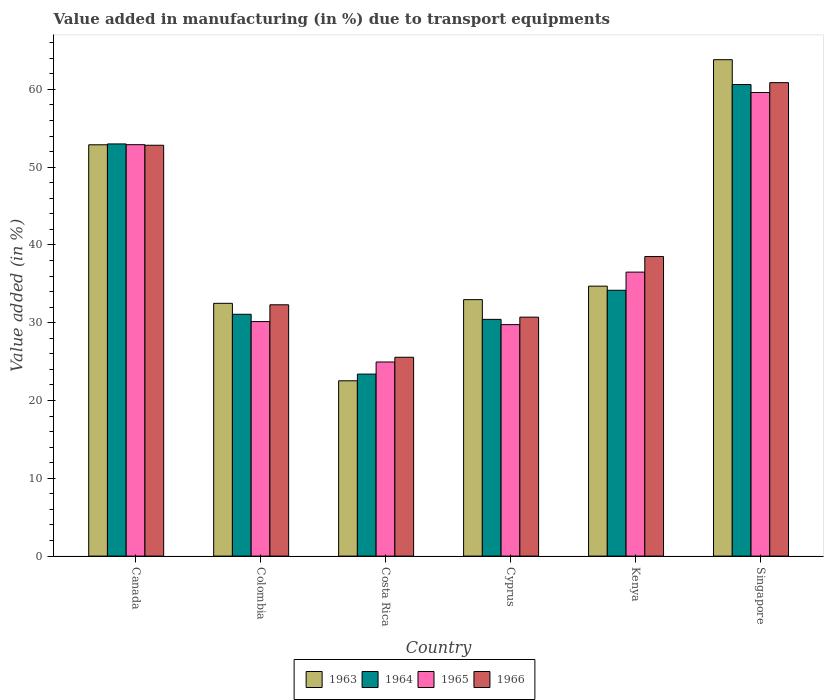How many different coloured bars are there?
Provide a succinct answer. 4. Are the number of bars per tick equal to the number of legend labels?
Your answer should be very brief. Yes. What is the label of the 1st group of bars from the left?
Your answer should be compact. Canada. In how many cases, is the number of bars for a given country not equal to the number of legend labels?
Offer a terse response. 0. What is the percentage of value added in manufacturing due to transport equipments in 1963 in Canada?
Ensure brevity in your answer.  52.87. Across all countries, what is the maximum percentage of value added in manufacturing due to transport equipments in 1965?
Your response must be concise. 59.59. Across all countries, what is the minimum percentage of value added in manufacturing due to transport equipments in 1963?
Your answer should be very brief. 22.53. In which country was the percentage of value added in manufacturing due to transport equipments in 1963 maximum?
Offer a terse response. Singapore. What is the total percentage of value added in manufacturing due to transport equipments in 1964 in the graph?
Make the answer very short. 232.68. What is the difference between the percentage of value added in manufacturing due to transport equipments in 1965 in Costa Rica and that in Kenya?
Make the answer very short. -11.55. What is the difference between the percentage of value added in manufacturing due to transport equipments in 1966 in Costa Rica and the percentage of value added in manufacturing due to transport equipments in 1964 in Cyprus?
Your answer should be compact. -4.87. What is the average percentage of value added in manufacturing due to transport equipments in 1965 per country?
Provide a short and direct response. 38.97. What is the difference between the percentage of value added in manufacturing due to transport equipments of/in 1965 and percentage of value added in manufacturing due to transport equipments of/in 1966 in Singapore?
Make the answer very short. -1.27. What is the ratio of the percentage of value added in manufacturing due to transport equipments in 1963 in Cyprus to that in Singapore?
Provide a succinct answer. 0.52. What is the difference between the highest and the second highest percentage of value added in manufacturing due to transport equipments in 1966?
Offer a terse response. -22.35. What is the difference between the highest and the lowest percentage of value added in manufacturing due to transport equipments in 1964?
Provide a succinct answer. 37.22. In how many countries, is the percentage of value added in manufacturing due to transport equipments in 1963 greater than the average percentage of value added in manufacturing due to transport equipments in 1963 taken over all countries?
Ensure brevity in your answer.  2. Is the sum of the percentage of value added in manufacturing due to transport equipments in 1964 in Colombia and Kenya greater than the maximum percentage of value added in manufacturing due to transport equipments in 1966 across all countries?
Your answer should be compact. Yes. Is it the case that in every country, the sum of the percentage of value added in manufacturing due to transport equipments in 1966 and percentage of value added in manufacturing due to transport equipments in 1964 is greater than the sum of percentage of value added in manufacturing due to transport equipments in 1965 and percentage of value added in manufacturing due to transport equipments in 1963?
Your answer should be very brief. No. What does the 2nd bar from the left in Singapore represents?
Provide a succinct answer. 1964. What does the 2nd bar from the right in Kenya represents?
Give a very brief answer. 1965. Is it the case that in every country, the sum of the percentage of value added in manufacturing due to transport equipments in 1963 and percentage of value added in manufacturing due to transport equipments in 1966 is greater than the percentage of value added in manufacturing due to transport equipments in 1964?
Make the answer very short. Yes. Are all the bars in the graph horizontal?
Your answer should be compact. No. What is the difference between two consecutive major ticks on the Y-axis?
Give a very brief answer. 10. Does the graph contain grids?
Keep it short and to the point. No. Where does the legend appear in the graph?
Keep it short and to the point. Bottom center. What is the title of the graph?
Keep it short and to the point. Value added in manufacturing (in %) due to transport equipments. What is the label or title of the Y-axis?
Make the answer very short. Value added (in %). What is the Value added (in %) of 1963 in Canada?
Your answer should be very brief. 52.87. What is the Value added (in %) in 1964 in Canada?
Make the answer very short. 52.98. What is the Value added (in %) of 1965 in Canada?
Your answer should be very brief. 52.89. What is the Value added (in %) in 1966 in Canada?
Your answer should be very brief. 52.81. What is the Value added (in %) in 1963 in Colombia?
Ensure brevity in your answer.  32.49. What is the Value added (in %) of 1964 in Colombia?
Offer a very short reply. 31.09. What is the Value added (in %) in 1965 in Colombia?
Your answer should be very brief. 30.15. What is the Value added (in %) in 1966 in Colombia?
Give a very brief answer. 32.3. What is the Value added (in %) of 1963 in Costa Rica?
Offer a very short reply. 22.53. What is the Value added (in %) in 1964 in Costa Rica?
Ensure brevity in your answer.  23.4. What is the Value added (in %) in 1965 in Costa Rica?
Your response must be concise. 24.95. What is the Value added (in %) in 1966 in Costa Rica?
Keep it short and to the point. 25.56. What is the Value added (in %) in 1963 in Cyprus?
Your answer should be very brief. 32.97. What is the Value added (in %) in 1964 in Cyprus?
Offer a terse response. 30.43. What is the Value added (in %) of 1965 in Cyprus?
Make the answer very short. 29.75. What is the Value added (in %) of 1966 in Cyprus?
Offer a very short reply. 30.72. What is the Value added (in %) of 1963 in Kenya?
Provide a short and direct response. 34.7. What is the Value added (in %) of 1964 in Kenya?
Your answer should be very brief. 34.17. What is the Value added (in %) of 1965 in Kenya?
Ensure brevity in your answer.  36.5. What is the Value added (in %) in 1966 in Kenya?
Your answer should be very brief. 38.51. What is the Value added (in %) of 1963 in Singapore?
Ensure brevity in your answer.  63.81. What is the Value added (in %) in 1964 in Singapore?
Offer a very short reply. 60.62. What is the Value added (in %) of 1965 in Singapore?
Provide a succinct answer. 59.59. What is the Value added (in %) in 1966 in Singapore?
Your answer should be compact. 60.86. Across all countries, what is the maximum Value added (in %) of 1963?
Make the answer very short. 63.81. Across all countries, what is the maximum Value added (in %) of 1964?
Keep it short and to the point. 60.62. Across all countries, what is the maximum Value added (in %) in 1965?
Your response must be concise. 59.59. Across all countries, what is the maximum Value added (in %) in 1966?
Provide a succinct answer. 60.86. Across all countries, what is the minimum Value added (in %) in 1963?
Make the answer very short. 22.53. Across all countries, what is the minimum Value added (in %) in 1964?
Keep it short and to the point. 23.4. Across all countries, what is the minimum Value added (in %) in 1965?
Make the answer very short. 24.95. Across all countries, what is the minimum Value added (in %) in 1966?
Your answer should be very brief. 25.56. What is the total Value added (in %) of 1963 in the graph?
Make the answer very short. 239.38. What is the total Value added (in %) in 1964 in the graph?
Your response must be concise. 232.68. What is the total Value added (in %) in 1965 in the graph?
Offer a very short reply. 233.83. What is the total Value added (in %) in 1966 in the graph?
Offer a very short reply. 240.76. What is the difference between the Value added (in %) of 1963 in Canada and that in Colombia?
Offer a terse response. 20.38. What is the difference between the Value added (in %) of 1964 in Canada and that in Colombia?
Your response must be concise. 21.9. What is the difference between the Value added (in %) in 1965 in Canada and that in Colombia?
Your answer should be very brief. 22.74. What is the difference between the Value added (in %) in 1966 in Canada and that in Colombia?
Keep it short and to the point. 20.51. What is the difference between the Value added (in %) of 1963 in Canada and that in Costa Rica?
Make the answer very short. 30.34. What is the difference between the Value added (in %) of 1964 in Canada and that in Costa Rica?
Your response must be concise. 29.59. What is the difference between the Value added (in %) of 1965 in Canada and that in Costa Rica?
Give a very brief answer. 27.93. What is the difference between the Value added (in %) of 1966 in Canada and that in Costa Rica?
Your answer should be compact. 27.25. What is the difference between the Value added (in %) in 1963 in Canada and that in Cyprus?
Give a very brief answer. 19.91. What is the difference between the Value added (in %) of 1964 in Canada and that in Cyprus?
Offer a terse response. 22.55. What is the difference between the Value added (in %) in 1965 in Canada and that in Cyprus?
Offer a terse response. 23.13. What is the difference between the Value added (in %) of 1966 in Canada and that in Cyprus?
Ensure brevity in your answer.  22.1. What is the difference between the Value added (in %) of 1963 in Canada and that in Kenya?
Provide a short and direct response. 18.17. What is the difference between the Value added (in %) in 1964 in Canada and that in Kenya?
Offer a very short reply. 18.81. What is the difference between the Value added (in %) of 1965 in Canada and that in Kenya?
Offer a terse response. 16.38. What is the difference between the Value added (in %) of 1966 in Canada and that in Kenya?
Your response must be concise. 14.3. What is the difference between the Value added (in %) in 1963 in Canada and that in Singapore?
Make the answer very short. -10.94. What is the difference between the Value added (in %) in 1964 in Canada and that in Singapore?
Your answer should be compact. -7.63. What is the difference between the Value added (in %) in 1965 in Canada and that in Singapore?
Offer a very short reply. -6.71. What is the difference between the Value added (in %) in 1966 in Canada and that in Singapore?
Your answer should be very brief. -8.05. What is the difference between the Value added (in %) in 1963 in Colombia and that in Costa Rica?
Provide a short and direct response. 9.96. What is the difference between the Value added (in %) in 1964 in Colombia and that in Costa Rica?
Ensure brevity in your answer.  7.69. What is the difference between the Value added (in %) of 1965 in Colombia and that in Costa Rica?
Your answer should be compact. 5.2. What is the difference between the Value added (in %) of 1966 in Colombia and that in Costa Rica?
Provide a short and direct response. 6.74. What is the difference between the Value added (in %) in 1963 in Colombia and that in Cyprus?
Offer a very short reply. -0.47. What is the difference between the Value added (in %) of 1964 in Colombia and that in Cyprus?
Offer a very short reply. 0.66. What is the difference between the Value added (in %) in 1965 in Colombia and that in Cyprus?
Make the answer very short. 0.39. What is the difference between the Value added (in %) in 1966 in Colombia and that in Cyprus?
Offer a terse response. 1.59. What is the difference between the Value added (in %) of 1963 in Colombia and that in Kenya?
Offer a very short reply. -2.21. What is the difference between the Value added (in %) of 1964 in Colombia and that in Kenya?
Ensure brevity in your answer.  -3.08. What is the difference between the Value added (in %) of 1965 in Colombia and that in Kenya?
Make the answer very short. -6.36. What is the difference between the Value added (in %) in 1966 in Colombia and that in Kenya?
Offer a very short reply. -6.2. What is the difference between the Value added (in %) of 1963 in Colombia and that in Singapore?
Give a very brief answer. -31.32. What is the difference between the Value added (in %) in 1964 in Colombia and that in Singapore?
Provide a short and direct response. -29.53. What is the difference between the Value added (in %) in 1965 in Colombia and that in Singapore?
Make the answer very short. -29.45. What is the difference between the Value added (in %) of 1966 in Colombia and that in Singapore?
Offer a terse response. -28.56. What is the difference between the Value added (in %) in 1963 in Costa Rica and that in Cyprus?
Offer a very short reply. -10.43. What is the difference between the Value added (in %) of 1964 in Costa Rica and that in Cyprus?
Make the answer very short. -7.03. What is the difference between the Value added (in %) of 1965 in Costa Rica and that in Cyprus?
Your answer should be very brief. -4.8. What is the difference between the Value added (in %) of 1966 in Costa Rica and that in Cyprus?
Provide a succinct answer. -5.16. What is the difference between the Value added (in %) in 1963 in Costa Rica and that in Kenya?
Offer a terse response. -12.17. What is the difference between the Value added (in %) of 1964 in Costa Rica and that in Kenya?
Give a very brief answer. -10.77. What is the difference between the Value added (in %) in 1965 in Costa Rica and that in Kenya?
Give a very brief answer. -11.55. What is the difference between the Value added (in %) in 1966 in Costa Rica and that in Kenya?
Your answer should be very brief. -12.95. What is the difference between the Value added (in %) of 1963 in Costa Rica and that in Singapore?
Ensure brevity in your answer.  -41.28. What is the difference between the Value added (in %) of 1964 in Costa Rica and that in Singapore?
Offer a terse response. -37.22. What is the difference between the Value added (in %) of 1965 in Costa Rica and that in Singapore?
Provide a succinct answer. -34.64. What is the difference between the Value added (in %) of 1966 in Costa Rica and that in Singapore?
Your answer should be compact. -35.3. What is the difference between the Value added (in %) of 1963 in Cyprus and that in Kenya?
Keep it short and to the point. -1.73. What is the difference between the Value added (in %) in 1964 in Cyprus and that in Kenya?
Your answer should be very brief. -3.74. What is the difference between the Value added (in %) of 1965 in Cyprus and that in Kenya?
Make the answer very short. -6.75. What is the difference between the Value added (in %) of 1966 in Cyprus and that in Kenya?
Provide a short and direct response. -7.79. What is the difference between the Value added (in %) of 1963 in Cyprus and that in Singapore?
Provide a succinct answer. -30.84. What is the difference between the Value added (in %) in 1964 in Cyprus and that in Singapore?
Make the answer very short. -30.19. What is the difference between the Value added (in %) in 1965 in Cyprus and that in Singapore?
Your answer should be very brief. -29.84. What is the difference between the Value added (in %) in 1966 in Cyprus and that in Singapore?
Give a very brief answer. -30.14. What is the difference between the Value added (in %) of 1963 in Kenya and that in Singapore?
Provide a succinct answer. -29.11. What is the difference between the Value added (in %) of 1964 in Kenya and that in Singapore?
Your response must be concise. -26.45. What is the difference between the Value added (in %) of 1965 in Kenya and that in Singapore?
Your answer should be very brief. -23.09. What is the difference between the Value added (in %) in 1966 in Kenya and that in Singapore?
Your response must be concise. -22.35. What is the difference between the Value added (in %) of 1963 in Canada and the Value added (in %) of 1964 in Colombia?
Provide a succinct answer. 21.79. What is the difference between the Value added (in %) in 1963 in Canada and the Value added (in %) in 1965 in Colombia?
Provide a succinct answer. 22.73. What is the difference between the Value added (in %) of 1963 in Canada and the Value added (in %) of 1966 in Colombia?
Make the answer very short. 20.57. What is the difference between the Value added (in %) of 1964 in Canada and the Value added (in %) of 1965 in Colombia?
Provide a succinct answer. 22.84. What is the difference between the Value added (in %) in 1964 in Canada and the Value added (in %) in 1966 in Colombia?
Your answer should be very brief. 20.68. What is the difference between the Value added (in %) in 1965 in Canada and the Value added (in %) in 1966 in Colombia?
Provide a succinct answer. 20.58. What is the difference between the Value added (in %) of 1963 in Canada and the Value added (in %) of 1964 in Costa Rica?
Provide a short and direct response. 29.48. What is the difference between the Value added (in %) of 1963 in Canada and the Value added (in %) of 1965 in Costa Rica?
Your answer should be compact. 27.92. What is the difference between the Value added (in %) of 1963 in Canada and the Value added (in %) of 1966 in Costa Rica?
Give a very brief answer. 27.31. What is the difference between the Value added (in %) of 1964 in Canada and the Value added (in %) of 1965 in Costa Rica?
Ensure brevity in your answer.  28.03. What is the difference between the Value added (in %) in 1964 in Canada and the Value added (in %) in 1966 in Costa Rica?
Offer a terse response. 27.42. What is the difference between the Value added (in %) in 1965 in Canada and the Value added (in %) in 1966 in Costa Rica?
Ensure brevity in your answer.  27.33. What is the difference between the Value added (in %) of 1963 in Canada and the Value added (in %) of 1964 in Cyprus?
Make the answer very short. 22.44. What is the difference between the Value added (in %) in 1963 in Canada and the Value added (in %) in 1965 in Cyprus?
Keep it short and to the point. 23.12. What is the difference between the Value added (in %) in 1963 in Canada and the Value added (in %) in 1966 in Cyprus?
Offer a very short reply. 22.16. What is the difference between the Value added (in %) in 1964 in Canada and the Value added (in %) in 1965 in Cyprus?
Offer a very short reply. 23.23. What is the difference between the Value added (in %) of 1964 in Canada and the Value added (in %) of 1966 in Cyprus?
Your answer should be compact. 22.27. What is the difference between the Value added (in %) in 1965 in Canada and the Value added (in %) in 1966 in Cyprus?
Keep it short and to the point. 22.17. What is the difference between the Value added (in %) of 1963 in Canada and the Value added (in %) of 1964 in Kenya?
Your answer should be very brief. 18.7. What is the difference between the Value added (in %) of 1963 in Canada and the Value added (in %) of 1965 in Kenya?
Provide a short and direct response. 16.37. What is the difference between the Value added (in %) of 1963 in Canada and the Value added (in %) of 1966 in Kenya?
Offer a terse response. 14.37. What is the difference between the Value added (in %) of 1964 in Canada and the Value added (in %) of 1965 in Kenya?
Provide a short and direct response. 16.48. What is the difference between the Value added (in %) of 1964 in Canada and the Value added (in %) of 1966 in Kenya?
Your answer should be compact. 14.47. What is the difference between the Value added (in %) in 1965 in Canada and the Value added (in %) in 1966 in Kenya?
Your answer should be very brief. 14.38. What is the difference between the Value added (in %) of 1963 in Canada and the Value added (in %) of 1964 in Singapore?
Provide a short and direct response. -7.74. What is the difference between the Value added (in %) in 1963 in Canada and the Value added (in %) in 1965 in Singapore?
Your answer should be very brief. -6.72. What is the difference between the Value added (in %) of 1963 in Canada and the Value added (in %) of 1966 in Singapore?
Ensure brevity in your answer.  -7.99. What is the difference between the Value added (in %) in 1964 in Canada and the Value added (in %) in 1965 in Singapore?
Give a very brief answer. -6.61. What is the difference between the Value added (in %) of 1964 in Canada and the Value added (in %) of 1966 in Singapore?
Keep it short and to the point. -7.88. What is the difference between the Value added (in %) of 1965 in Canada and the Value added (in %) of 1966 in Singapore?
Your response must be concise. -7.97. What is the difference between the Value added (in %) of 1963 in Colombia and the Value added (in %) of 1964 in Costa Rica?
Make the answer very short. 9.1. What is the difference between the Value added (in %) in 1963 in Colombia and the Value added (in %) in 1965 in Costa Rica?
Offer a very short reply. 7.54. What is the difference between the Value added (in %) in 1963 in Colombia and the Value added (in %) in 1966 in Costa Rica?
Give a very brief answer. 6.93. What is the difference between the Value added (in %) in 1964 in Colombia and the Value added (in %) in 1965 in Costa Rica?
Provide a short and direct response. 6.14. What is the difference between the Value added (in %) in 1964 in Colombia and the Value added (in %) in 1966 in Costa Rica?
Your response must be concise. 5.53. What is the difference between the Value added (in %) in 1965 in Colombia and the Value added (in %) in 1966 in Costa Rica?
Offer a very short reply. 4.59. What is the difference between the Value added (in %) in 1963 in Colombia and the Value added (in %) in 1964 in Cyprus?
Offer a very short reply. 2.06. What is the difference between the Value added (in %) in 1963 in Colombia and the Value added (in %) in 1965 in Cyprus?
Provide a short and direct response. 2.74. What is the difference between the Value added (in %) in 1963 in Colombia and the Value added (in %) in 1966 in Cyprus?
Your answer should be very brief. 1.78. What is the difference between the Value added (in %) in 1964 in Colombia and the Value added (in %) in 1965 in Cyprus?
Provide a succinct answer. 1.33. What is the difference between the Value added (in %) of 1964 in Colombia and the Value added (in %) of 1966 in Cyprus?
Offer a very short reply. 0.37. What is the difference between the Value added (in %) in 1965 in Colombia and the Value added (in %) in 1966 in Cyprus?
Your answer should be very brief. -0.57. What is the difference between the Value added (in %) in 1963 in Colombia and the Value added (in %) in 1964 in Kenya?
Provide a succinct answer. -1.68. What is the difference between the Value added (in %) of 1963 in Colombia and the Value added (in %) of 1965 in Kenya?
Provide a short and direct response. -4.01. What is the difference between the Value added (in %) of 1963 in Colombia and the Value added (in %) of 1966 in Kenya?
Make the answer very short. -6.01. What is the difference between the Value added (in %) in 1964 in Colombia and the Value added (in %) in 1965 in Kenya?
Ensure brevity in your answer.  -5.42. What is the difference between the Value added (in %) of 1964 in Colombia and the Value added (in %) of 1966 in Kenya?
Offer a very short reply. -7.42. What is the difference between the Value added (in %) in 1965 in Colombia and the Value added (in %) in 1966 in Kenya?
Your response must be concise. -8.36. What is the difference between the Value added (in %) in 1963 in Colombia and the Value added (in %) in 1964 in Singapore?
Make the answer very short. -28.12. What is the difference between the Value added (in %) of 1963 in Colombia and the Value added (in %) of 1965 in Singapore?
Your answer should be very brief. -27.1. What is the difference between the Value added (in %) of 1963 in Colombia and the Value added (in %) of 1966 in Singapore?
Your answer should be compact. -28.37. What is the difference between the Value added (in %) in 1964 in Colombia and the Value added (in %) in 1965 in Singapore?
Make the answer very short. -28.51. What is the difference between the Value added (in %) in 1964 in Colombia and the Value added (in %) in 1966 in Singapore?
Your answer should be very brief. -29.77. What is the difference between the Value added (in %) in 1965 in Colombia and the Value added (in %) in 1966 in Singapore?
Offer a very short reply. -30.71. What is the difference between the Value added (in %) in 1963 in Costa Rica and the Value added (in %) in 1964 in Cyprus?
Offer a very short reply. -7.9. What is the difference between the Value added (in %) of 1963 in Costa Rica and the Value added (in %) of 1965 in Cyprus?
Make the answer very short. -7.22. What is the difference between the Value added (in %) of 1963 in Costa Rica and the Value added (in %) of 1966 in Cyprus?
Provide a short and direct response. -8.18. What is the difference between the Value added (in %) of 1964 in Costa Rica and the Value added (in %) of 1965 in Cyprus?
Provide a succinct answer. -6.36. What is the difference between the Value added (in %) of 1964 in Costa Rica and the Value added (in %) of 1966 in Cyprus?
Give a very brief answer. -7.32. What is the difference between the Value added (in %) in 1965 in Costa Rica and the Value added (in %) in 1966 in Cyprus?
Offer a very short reply. -5.77. What is the difference between the Value added (in %) in 1963 in Costa Rica and the Value added (in %) in 1964 in Kenya?
Provide a short and direct response. -11.64. What is the difference between the Value added (in %) of 1963 in Costa Rica and the Value added (in %) of 1965 in Kenya?
Provide a succinct answer. -13.97. What is the difference between the Value added (in %) in 1963 in Costa Rica and the Value added (in %) in 1966 in Kenya?
Your answer should be compact. -15.97. What is the difference between the Value added (in %) in 1964 in Costa Rica and the Value added (in %) in 1965 in Kenya?
Make the answer very short. -13.11. What is the difference between the Value added (in %) of 1964 in Costa Rica and the Value added (in %) of 1966 in Kenya?
Provide a succinct answer. -15.11. What is the difference between the Value added (in %) in 1965 in Costa Rica and the Value added (in %) in 1966 in Kenya?
Provide a succinct answer. -13.56. What is the difference between the Value added (in %) of 1963 in Costa Rica and the Value added (in %) of 1964 in Singapore?
Your response must be concise. -38.08. What is the difference between the Value added (in %) in 1963 in Costa Rica and the Value added (in %) in 1965 in Singapore?
Offer a very short reply. -37.06. What is the difference between the Value added (in %) of 1963 in Costa Rica and the Value added (in %) of 1966 in Singapore?
Your answer should be compact. -38.33. What is the difference between the Value added (in %) in 1964 in Costa Rica and the Value added (in %) in 1965 in Singapore?
Provide a succinct answer. -36.19. What is the difference between the Value added (in %) of 1964 in Costa Rica and the Value added (in %) of 1966 in Singapore?
Provide a short and direct response. -37.46. What is the difference between the Value added (in %) in 1965 in Costa Rica and the Value added (in %) in 1966 in Singapore?
Keep it short and to the point. -35.91. What is the difference between the Value added (in %) of 1963 in Cyprus and the Value added (in %) of 1964 in Kenya?
Ensure brevity in your answer.  -1.2. What is the difference between the Value added (in %) of 1963 in Cyprus and the Value added (in %) of 1965 in Kenya?
Keep it short and to the point. -3.54. What is the difference between the Value added (in %) of 1963 in Cyprus and the Value added (in %) of 1966 in Kenya?
Offer a very short reply. -5.54. What is the difference between the Value added (in %) in 1964 in Cyprus and the Value added (in %) in 1965 in Kenya?
Your answer should be compact. -6.07. What is the difference between the Value added (in %) in 1964 in Cyprus and the Value added (in %) in 1966 in Kenya?
Provide a short and direct response. -8.08. What is the difference between the Value added (in %) of 1965 in Cyprus and the Value added (in %) of 1966 in Kenya?
Provide a short and direct response. -8.75. What is the difference between the Value added (in %) in 1963 in Cyprus and the Value added (in %) in 1964 in Singapore?
Make the answer very short. -27.65. What is the difference between the Value added (in %) in 1963 in Cyprus and the Value added (in %) in 1965 in Singapore?
Offer a very short reply. -26.62. What is the difference between the Value added (in %) of 1963 in Cyprus and the Value added (in %) of 1966 in Singapore?
Keep it short and to the point. -27.89. What is the difference between the Value added (in %) in 1964 in Cyprus and the Value added (in %) in 1965 in Singapore?
Your answer should be very brief. -29.16. What is the difference between the Value added (in %) of 1964 in Cyprus and the Value added (in %) of 1966 in Singapore?
Make the answer very short. -30.43. What is the difference between the Value added (in %) of 1965 in Cyprus and the Value added (in %) of 1966 in Singapore?
Your response must be concise. -31.11. What is the difference between the Value added (in %) of 1963 in Kenya and the Value added (in %) of 1964 in Singapore?
Make the answer very short. -25.92. What is the difference between the Value added (in %) in 1963 in Kenya and the Value added (in %) in 1965 in Singapore?
Your answer should be very brief. -24.89. What is the difference between the Value added (in %) of 1963 in Kenya and the Value added (in %) of 1966 in Singapore?
Your answer should be compact. -26.16. What is the difference between the Value added (in %) in 1964 in Kenya and the Value added (in %) in 1965 in Singapore?
Your answer should be compact. -25.42. What is the difference between the Value added (in %) in 1964 in Kenya and the Value added (in %) in 1966 in Singapore?
Offer a very short reply. -26.69. What is the difference between the Value added (in %) in 1965 in Kenya and the Value added (in %) in 1966 in Singapore?
Provide a succinct answer. -24.36. What is the average Value added (in %) in 1963 per country?
Your answer should be compact. 39.9. What is the average Value added (in %) of 1964 per country?
Offer a very short reply. 38.78. What is the average Value added (in %) in 1965 per country?
Make the answer very short. 38.97. What is the average Value added (in %) of 1966 per country?
Offer a very short reply. 40.13. What is the difference between the Value added (in %) of 1963 and Value added (in %) of 1964 in Canada?
Make the answer very short. -0.11. What is the difference between the Value added (in %) in 1963 and Value added (in %) in 1965 in Canada?
Provide a succinct answer. -0.01. What is the difference between the Value added (in %) of 1963 and Value added (in %) of 1966 in Canada?
Give a very brief answer. 0.06. What is the difference between the Value added (in %) in 1964 and Value added (in %) in 1965 in Canada?
Provide a succinct answer. 0.1. What is the difference between the Value added (in %) in 1964 and Value added (in %) in 1966 in Canada?
Keep it short and to the point. 0.17. What is the difference between the Value added (in %) of 1965 and Value added (in %) of 1966 in Canada?
Your answer should be compact. 0.07. What is the difference between the Value added (in %) in 1963 and Value added (in %) in 1964 in Colombia?
Offer a very short reply. 1.41. What is the difference between the Value added (in %) in 1963 and Value added (in %) in 1965 in Colombia?
Keep it short and to the point. 2.35. What is the difference between the Value added (in %) in 1963 and Value added (in %) in 1966 in Colombia?
Keep it short and to the point. 0.19. What is the difference between the Value added (in %) of 1964 and Value added (in %) of 1965 in Colombia?
Make the answer very short. 0.94. What is the difference between the Value added (in %) in 1964 and Value added (in %) in 1966 in Colombia?
Provide a succinct answer. -1.22. What is the difference between the Value added (in %) of 1965 and Value added (in %) of 1966 in Colombia?
Give a very brief answer. -2.16. What is the difference between the Value added (in %) in 1963 and Value added (in %) in 1964 in Costa Rica?
Your answer should be very brief. -0.86. What is the difference between the Value added (in %) of 1963 and Value added (in %) of 1965 in Costa Rica?
Offer a terse response. -2.42. What is the difference between the Value added (in %) of 1963 and Value added (in %) of 1966 in Costa Rica?
Offer a terse response. -3.03. What is the difference between the Value added (in %) of 1964 and Value added (in %) of 1965 in Costa Rica?
Your answer should be compact. -1.55. What is the difference between the Value added (in %) of 1964 and Value added (in %) of 1966 in Costa Rica?
Your response must be concise. -2.16. What is the difference between the Value added (in %) in 1965 and Value added (in %) in 1966 in Costa Rica?
Give a very brief answer. -0.61. What is the difference between the Value added (in %) of 1963 and Value added (in %) of 1964 in Cyprus?
Keep it short and to the point. 2.54. What is the difference between the Value added (in %) in 1963 and Value added (in %) in 1965 in Cyprus?
Give a very brief answer. 3.21. What is the difference between the Value added (in %) of 1963 and Value added (in %) of 1966 in Cyprus?
Provide a succinct answer. 2.25. What is the difference between the Value added (in %) of 1964 and Value added (in %) of 1965 in Cyprus?
Provide a short and direct response. 0.68. What is the difference between the Value added (in %) of 1964 and Value added (in %) of 1966 in Cyprus?
Your response must be concise. -0.29. What is the difference between the Value added (in %) of 1965 and Value added (in %) of 1966 in Cyprus?
Your response must be concise. -0.96. What is the difference between the Value added (in %) in 1963 and Value added (in %) in 1964 in Kenya?
Provide a succinct answer. 0.53. What is the difference between the Value added (in %) in 1963 and Value added (in %) in 1965 in Kenya?
Keep it short and to the point. -1.8. What is the difference between the Value added (in %) in 1963 and Value added (in %) in 1966 in Kenya?
Your response must be concise. -3.81. What is the difference between the Value added (in %) of 1964 and Value added (in %) of 1965 in Kenya?
Your response must be concise. -2.33. What is the difference between the Value added (in %) of 1964 and Value added (in %) of 1966 in Kenya?
Provide a short and direct response. -4.34. What is the difference between the Value added (in %) in 1965 and Value added (in %) in 1966 in Kenya?
Your response must be concise. -2. What is the difference between the Value added (in %) of 1963 and Value added (in %) of 1964 in Singapore?
Provide a succinct answer. 3.19. What is the difference between the Value added (in %) of 1963 and Value added (in %) of 1965 in Singapore?
Provide a short and direct response. 4.22. What is the difference between the Value added (in %) of 1963 and Value added (in %) of 1966 in Singapore?
Offer a very short reply. 2.95. What is the difference between the Value added (in %) in 1964 and Value added (in %) in 1965 in Singapore?
Make the answer very short. 1.03. What is the difference between the Value added (in %) of 1964 and Value added (in %) of 1966 in Singapore?
Offer a terse response. -0.24. What is the difference between the Value added (in %) of 1965 and Value added (in %) of 1966 in Singapore?
Keep it short and to the point. -1.27. What is the ratio of the Value added (in %) in 1963 in Canada to that in Colombia?
Offer a very short reply. 1.63. What is the ratio of the Value added (in %) of 1964 in Canada to that in Colombia?
Make the answer very short. 1.7. What is the ratio of the Value added (in %) of 1965 in Canada to that in Colombia?
Give a very brief answer. 1.75. What is the ratio of the Value added (in %) in 1966 in Canada to that in Colombia?
Ensure brevity in your answer.  1.63. What is the ratio of the Value added (in %) in 1963 in Canada to that in Costa Rica?
Provide a short and direct response. 2.35. What is the ratio of the Value added (in %) of 1964 in Canada to that in Costa Rica?
Provide a succinct answer. 2.26. What is the ratio of the Value added (in %) of 1965 in Canada to that in Costa Rica?
Keep it short and to the point. 2.12. What is the ratio of the Value added (in %) of 1966 in Canada to that in Costa Rica?
Offer a very short reply. 2.07. What is the ratio of the Value added (in %) of 1963 in Canada to that in Cyprus?
Your answer should be very brief. 1.6. What is the ratio of the Value added (in %) of 1964 in Canada to that in Cyprus?
Your answer should be compact. 1.74. What is the ratio of the Value added (in %) in 1965 in Canada to that in Cyprus?
Make the answer very short. 1.78. What is the ratio of the Value added (in %) in 1966 in Canada to that in Cyprus?
Offer a terse response. 1.72. What is the ratio of the Value added (in %) of 1963 in Canada to that in Kenya?
Offer a terse response. 1.52. What is the ratio of the Value added (in %) in 1964 in Canada to that in Kenya?
Your answer should be compact. 1.55. What is the ratio of the Value added (in %) of 1965 in Canada to that in Kenya?
Keep it short and to the point. 1.45. What is the ratio of the Value added (in %) of 1966 in Canada to that in Kenya?
Give a very brief answer. 1.37. What is the ratio of the Value added (in %) in 1963 in Canada to that in Singapore?
Ensure brevity in your answer.  0.83. What is the ratio of the Value added (in %) in 1964 in Canada to that in Singapore?
Your answer should be compact. 0.87. What is the ratio of the Value added (in %) in 1965 in Canada to that in Singapore?
Provide a short and direct response. 0.89. What is the ratio of the Value added (in %) of 1966 in Canada to that in Singapore?
Offer a very short reply. 0.87. What is the ratio of the Value added (in %) of 1963 in Colombia to that in Costa Rica?
Offer a very short reply. 1.44. What is the ratio of the Value added (in %) in 1964 in Colombia to that in Costa Rica?
Keep it short and to the point. 1.33. What is the ratio of the Value added (in %) of 1965 in Colombia to that in Costa Rica?
Your answer should be compact. 1.21. What is the ratio of the Value added (in %) in 1966 in Colombia to that in Costa Rica?
Offer a very short reply. 1.26. What is the ratio of the Value added (in %) of 1963 in Colombia to that in Cyprus?
Provide a succinct answer. 0.99. What is the ratio of the Value added (in %) of 1964 in Colombia to that in Cyprus?
Offer a terse response. 1.02. What is the ratio of the Value added (in %) of 1965 in Colombia to that in Cyprus?
Ensure brevity in your answer.  1.01. What is the ratio of the Value added (in %) in 1966 in Colombia to that in Cyprus?
Provide a short and direct response. 1.05. What is the ratio of the Value added (in %) in 1963 in Colombia to that in Kenya?
Keep it short and to the point. 0.94. What is the ratio of the Value added (in %) of 1964 in Colombia to that in Kenya?
Keep it short and to the point. 0.91. What is the ratio of the Value added (in %) in 1965 in Colombia to that in Kenya?
Offer a very short reply. 0.83. What is the ratio of the Value added (in %) in 1966 in Colombia to that in Kenya?
Offer a terse response. 0.84. What is the ratio of the Value added (in %) of 1963 in Colombia to that in Singapore?
Ensure brevity in your answer.  0.51. What is the ratio of the Value added (in %) in 1964 in Colombia to that in Singapore?
Provide a succinct answer. 0.51. What is the ratio of the Value added (in %) of 1965 in Colombia to that in Singapore?
Your answer should be compact. 0.51. What is the ratio of the Value added (in %) in 1966 in Colombia to that in Singapore?
Give a very brief answer. 0.53. What is the ratio of the Value added (in %) of 1963 in Costa Rica to that in Cyprus?
Your response must be concise. 0.68. What is the ratio of the Value added (in %) of 1964 in Costa Rica to that in Cyprus?
Give a very brief answer. 0.77. What is the ratio of the Value added (in %) of 1965 in Costa Rica to that in Cyprus?
Offer a very short reply. 0.84. What is the ratio of the Value added (in %) of 1966 in Costa Rica to that in Cyprus?
Keep it short and to the point. 0.83. What is the ratio of the Value added (in %) of 1963 in Costa Rica to that in Kenya?
Provide a succinct answer. 0.65. What is the ratio of the Value added (in %) in 1964 in Costa Rica to that in Kenya?
Your response must be concise. 0.68. What is the ratio of the Value added (in %) of 1965 in Costa Rica to that in Kenya?
Offer a very short reply. 0.68. What is the ratio of the Value added (in %) of 1966 in Costa Rica to that in Kenya?
Provide a short and direct response. 0.66. What is the ratio of the Value added (in %) of 1963 in Costa Rica to that in Singapore?
Provide a succinct answer. 0.35. What is the ratio of the Value added (in %) in 1964 in Costa Rica to that in Singapore?
Your answer should be compact. 0.39. What is the ratio of the Value added (in %) in 1965 in Costa Rica to that in Singapore?
Your response must be concise. 0.42. What is the ratio of the Value added (in %) of 1966 in Costa Rica to that in Singapore?
Give a very brief answer. 0.42. What is the ratio of the Value added (in %) in 1963 in Cyprus to that in Kenya?
Keep it short and to the point. 0.95. What is the ratio of the Value added (in %) of 1964 in Cyprus to that in Kenya?
Ensure brevity in your answer.  0.89. What is the ratio of the Value added (in %) in 1965 in Cyprus to that in Kenya?
Provide a short and direct response. 0.82. What is the ratio of the Value added (in %) of 1966 in Cyprus to that in Kenya?
Your answer should be very brief. 0.8. What is the ratio of the Value added (in %) in 1963 in Cyprus to that in Singapore?
Ensure brevity in your answer.  0.52. What is the ratio of the Value added (in %) in 1964 in Cyprus to that in Singapore?
Provide a succinct answer. 0.5. What is the ratio of the Value added (in %) of 1965 in Cyprus to that in Singapore?
Provide a short and direct response. 0.5. What is the ratio of the Value added (in %) of 1966 in Cyprus to that in Singapore?
Ensure brevity in your answer.  0.5. What is the ratio of the Value added (in %) in 1963 in Kenya to that in Singapore?
Provide a short and direct response. 0.54. What is the ratio of the Value added (in %) in 1964 in Kenya to that in Singapore?
Your answer should be very brief. 0.56. What is the ratio of the Value added (in %) of 1965 in Kenya to that in Singapore?
Your answer should be compact. 0.61. What is the ratio of the Value added (in %) in 1966 in Kenya to that in Singapore?
Keep it short and to the point. 0.63. What is the difference between the highest and the second highest Value added (in %) in 1963?
Make the answer very short. 10.94. What is the difference between the highest and the second highest Value added (in %) of 1964?
Provide a short and direct response. 7.63. What is the difference between the highest and the second highest Value added (in %) in 1965?
Your response must be concise. 6.71. What is the difference between the highest and the second highest Value added (in %) in 1966?
Ensure brevity in your answer.  8.05. What is the difference between the highest and the lowest Value added (in %) of 1963?
Your answer should be compact. 41.28. What is the difference between the highest and the lowest Value added (in %) of 1964?
Offer a terse response. 37.22. What is the difference between the highest and the lowest Value added (in %) of 1965?
Provide a short and direct response. 34.64. What is the difference between the highest and the lowest Value added (in %) of 1966?
Keep it short and to the point. 35.3. 